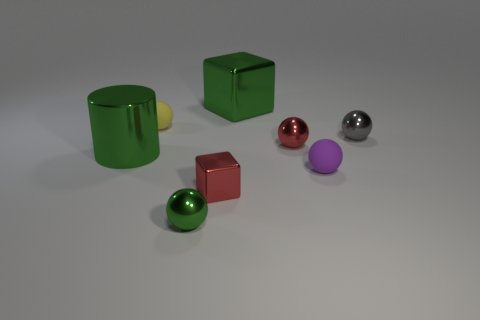Subtract all gray balls. How many balls are left? 4 Subtract all cyan balls. Subtract all cyan cubes. How many balls are left? 5 Add 2 tiny cyan shiny cylinders. How many objects exist? 10 Subtract all blocks. How many objects are left? 6 Add 1 red shiny blocks. How many red shiny blocks are left? 2 Add 6 red spheres. How many red spheres exist? 7 Subtract 0 purple cylinders. How many objects are left? 8 Subtract all green objects. Subtract all tiny purple objects. How many objects are left? 4 